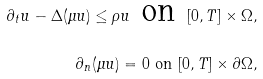Convert formula to latex. <formula><loc_0><loc_0><loc_500><loc_500>\partial _ { t } u - \Delta ( \mu u ) \leq \rho u \text { on } [ 0 , T ] \times \Omega , \\ \partial _ { n } ( \mu u ) = 0 \text { on } [ 0 , T ] \times \partial \Omega ,</formula> 